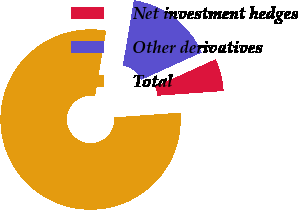Convert chart. <chart><loc_0><loc_0><loc_500><loc_500><pie_chart><fcel>Net investment hedges<fcel>Other derivatives<fcel>Total<nl><fcel>5.63%<fcel>15.56%<fcel>78.81%<nl></chart> 